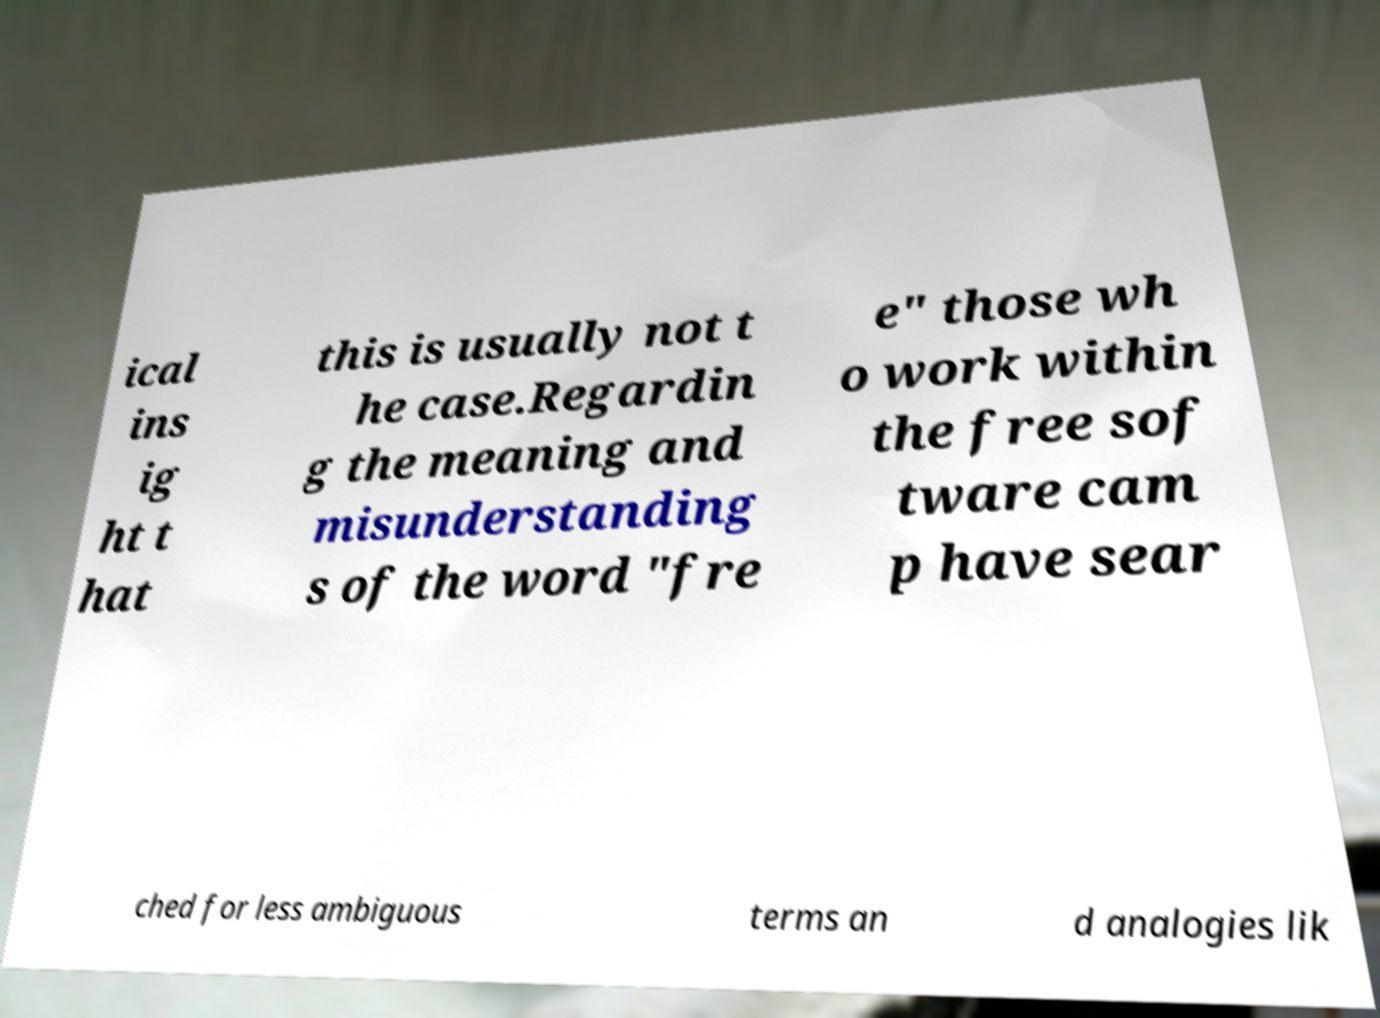Could you assist in decoding the text presented in this image and type it out clearly? ical ins ig ht t hat this is usually not t he case.Regardin g the meaning and misunderstanding s of the word "fre e" those wh o work within the free sof tware cam p have sear ched for less ambiguous terms an d analogies lik 